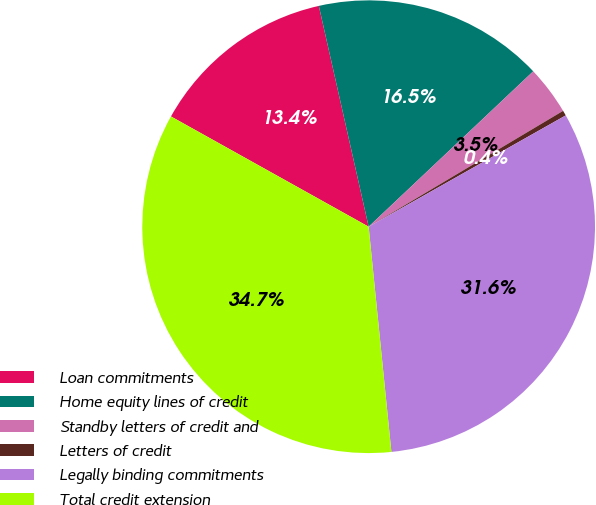<chart> <loc_0><loc_0><loc_500><loc_500><pie_chart><fcel>Loan commitments<fcel>Home equity lines of credit<fcel>Standby letters of credit and<fcel>Letters of credit<fcel>Legally binding commitments<fcel>Total credit extension<nl><fcel>13.37%<fcel>16.49%<fcel>3.49%<fcel>0.37%<fcel>31.58%<fcel>34.7%<nl></chart> 